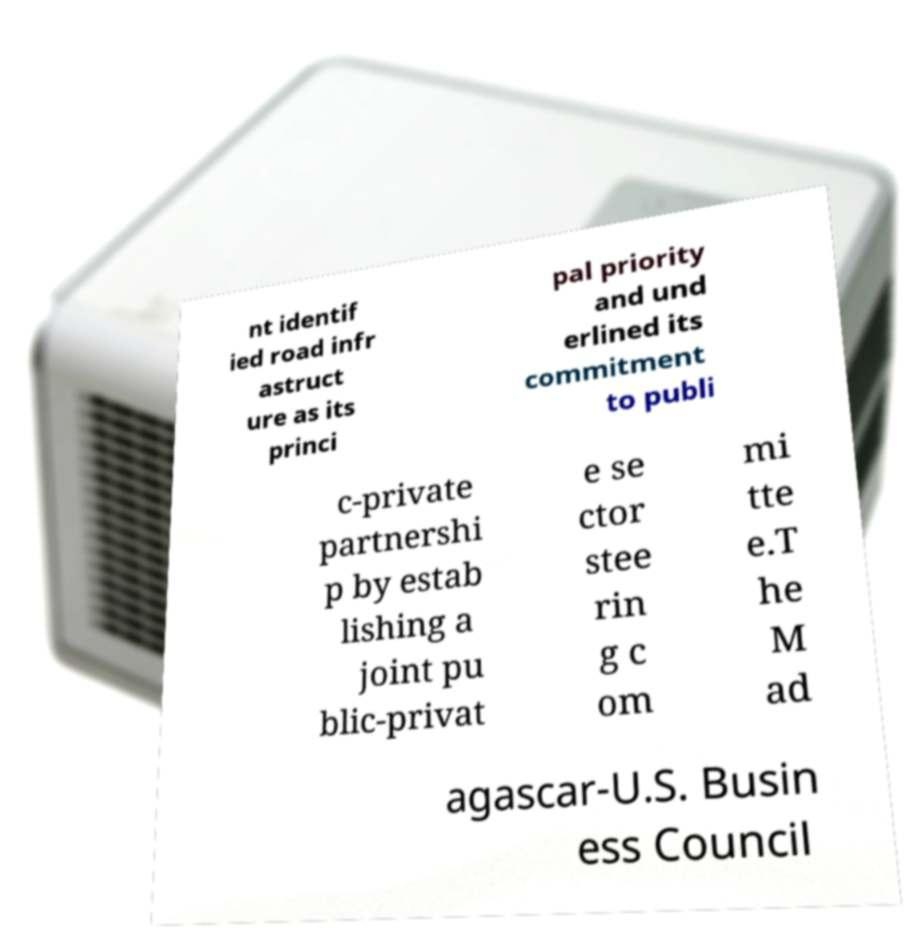Can you read and provide the text displayed in the image?This photo seems to have some interesting text. Can you extract and type it out for me? nt identif ied road infr astruct ure as its princi pal priority and und erlined its commitment to publi c-private partnershi p by estab lishing a joint pu blic-privat e se ctor stee rin g c om mi tte e.T he M ad agascar-U.S. Busin ess Council 